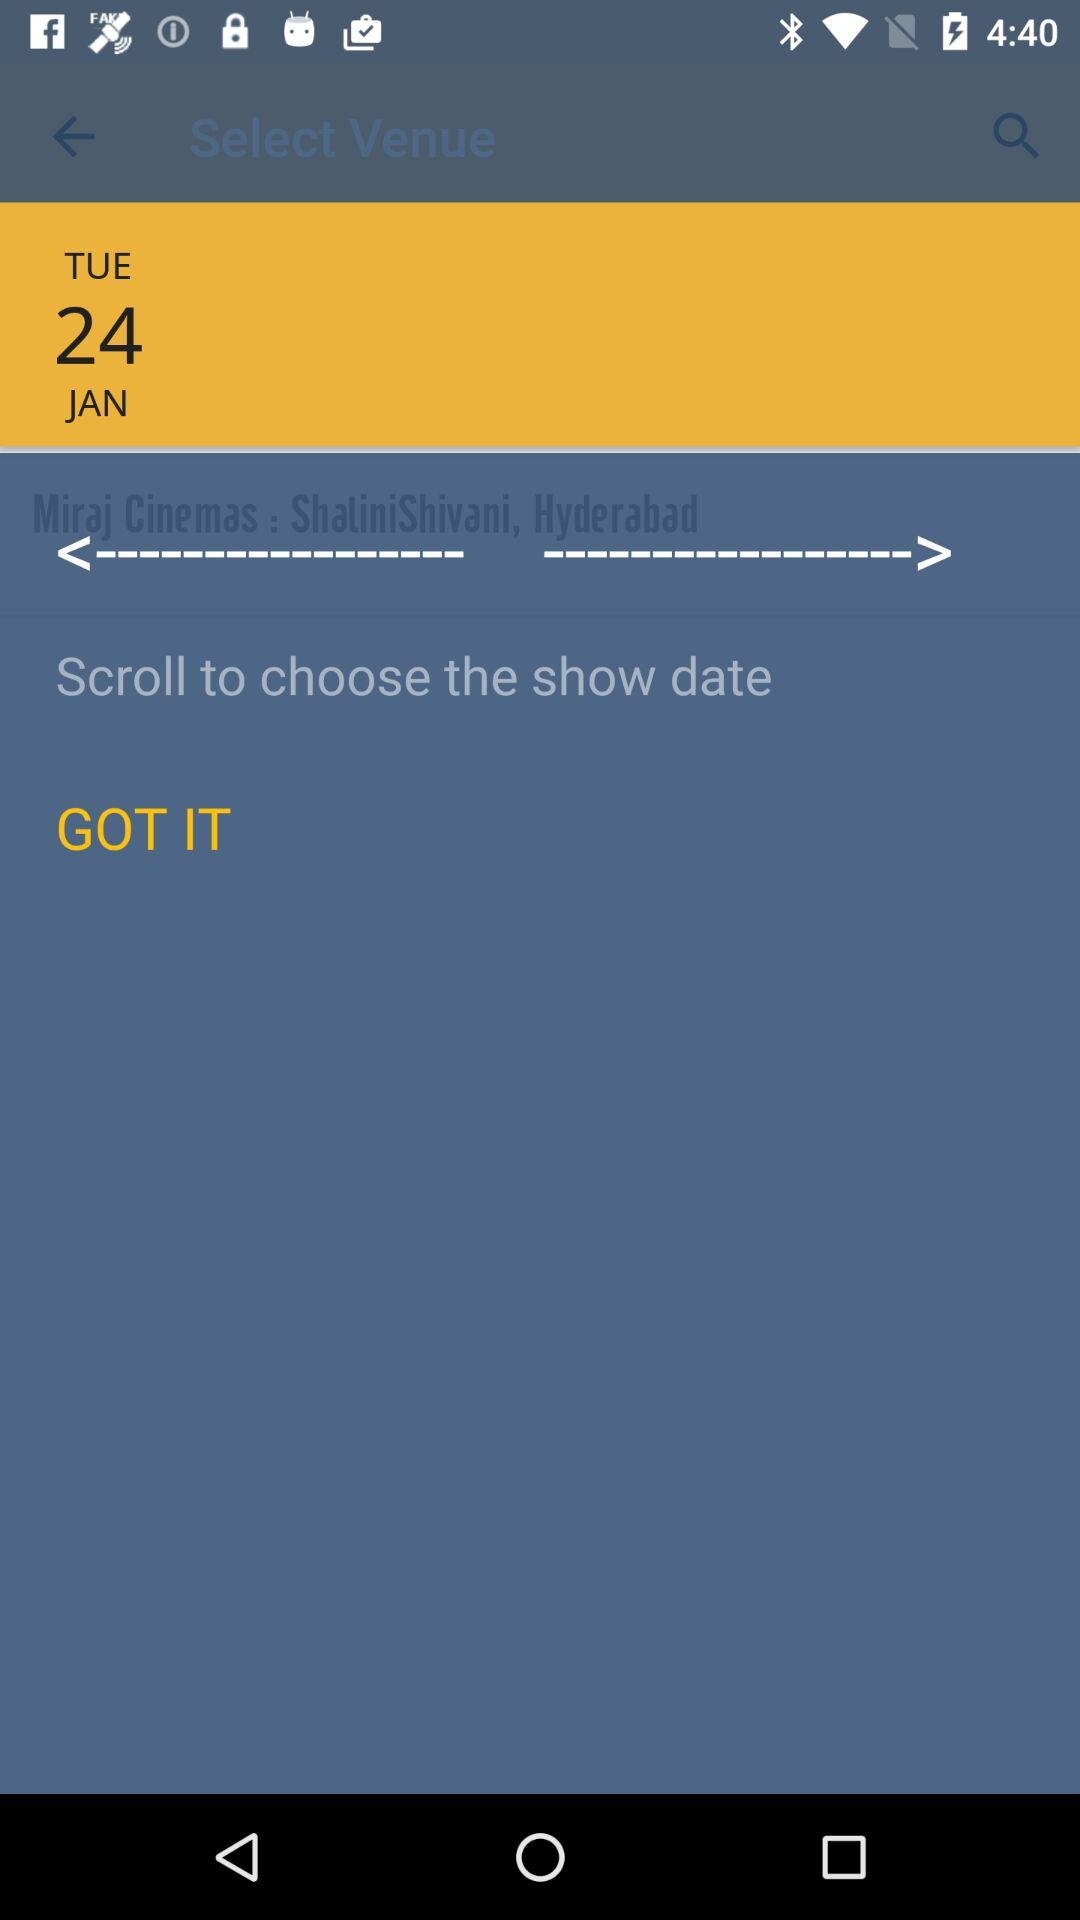What date is shown on the screen? The date is Tuesday, January 24. 